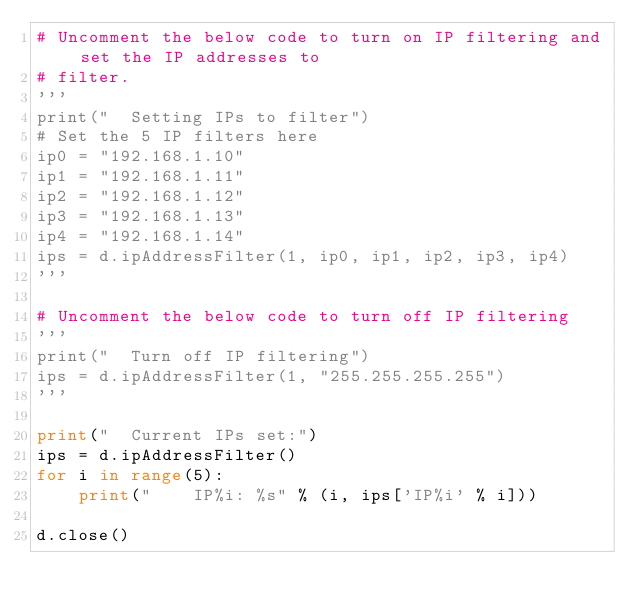<code> <loc_0><loc_0><loc_500><loc_500><_Python_># Uncomment the below code to turn on IP filtering and set the IP addresses to
# filter.
'''
print("  Setting IPs to filter")
# Set the 5 IP filters here
ip0 = "192.168.1.10"
ip1 = "192.168.1.11"
ip2 = "192.168.1.12"
ip3 = "192.168.1.13"
ip4 = "192.168.1.14"
ips = d.ipAddressFilter(1, ip0, ip1, ip2, ip3, ip4)
'''

# Uncomment the below code to turn off IP filtering
'''
print("  Turn off IP filtering")
ips = d.ipAddressFilter(1, "255.255.255.255")
'''

print("  Current IPs set:")
ips = d.ipAddressFilter()
for i in range(5):
    print("    IP%i: %s" % (i, ips['IP%i' % i]))

d.close()
</code> 